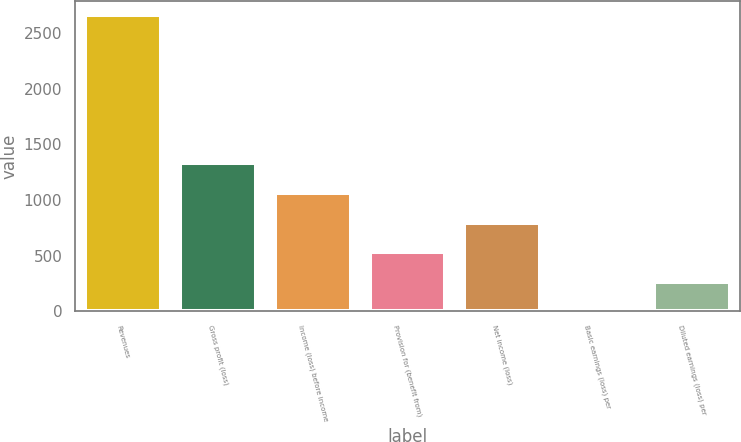<chart> <loc_0><loc_0><loc_500><loc_500><bar_chart><fcel>Revenues<fcel>Gross profit (loss)<fcel>Income (loss) before income<fcel>Provision for (benefit from)<fcel>Net income (loss)<fcel>Basic earnings (loss) per<fcel>Diluted earnings (loss) per<nl><fcel>2658.1<fcel>1329.11<fcel>1063.32<fcel>531.74<fcel>797.53<fcel>0.16<fcel>265.95<nl></chart> 